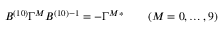<formula> <loc_0><loc_0><loc_500><loc_500>B ^ { ( 1 0 ) } \Gamma ^ { M } B ^ { ( 1 0 ) ^ { - 1 } = - \Gamma ^ { M ^ { * } \quad ( M = 0 , \dots , 9 )</formula> 